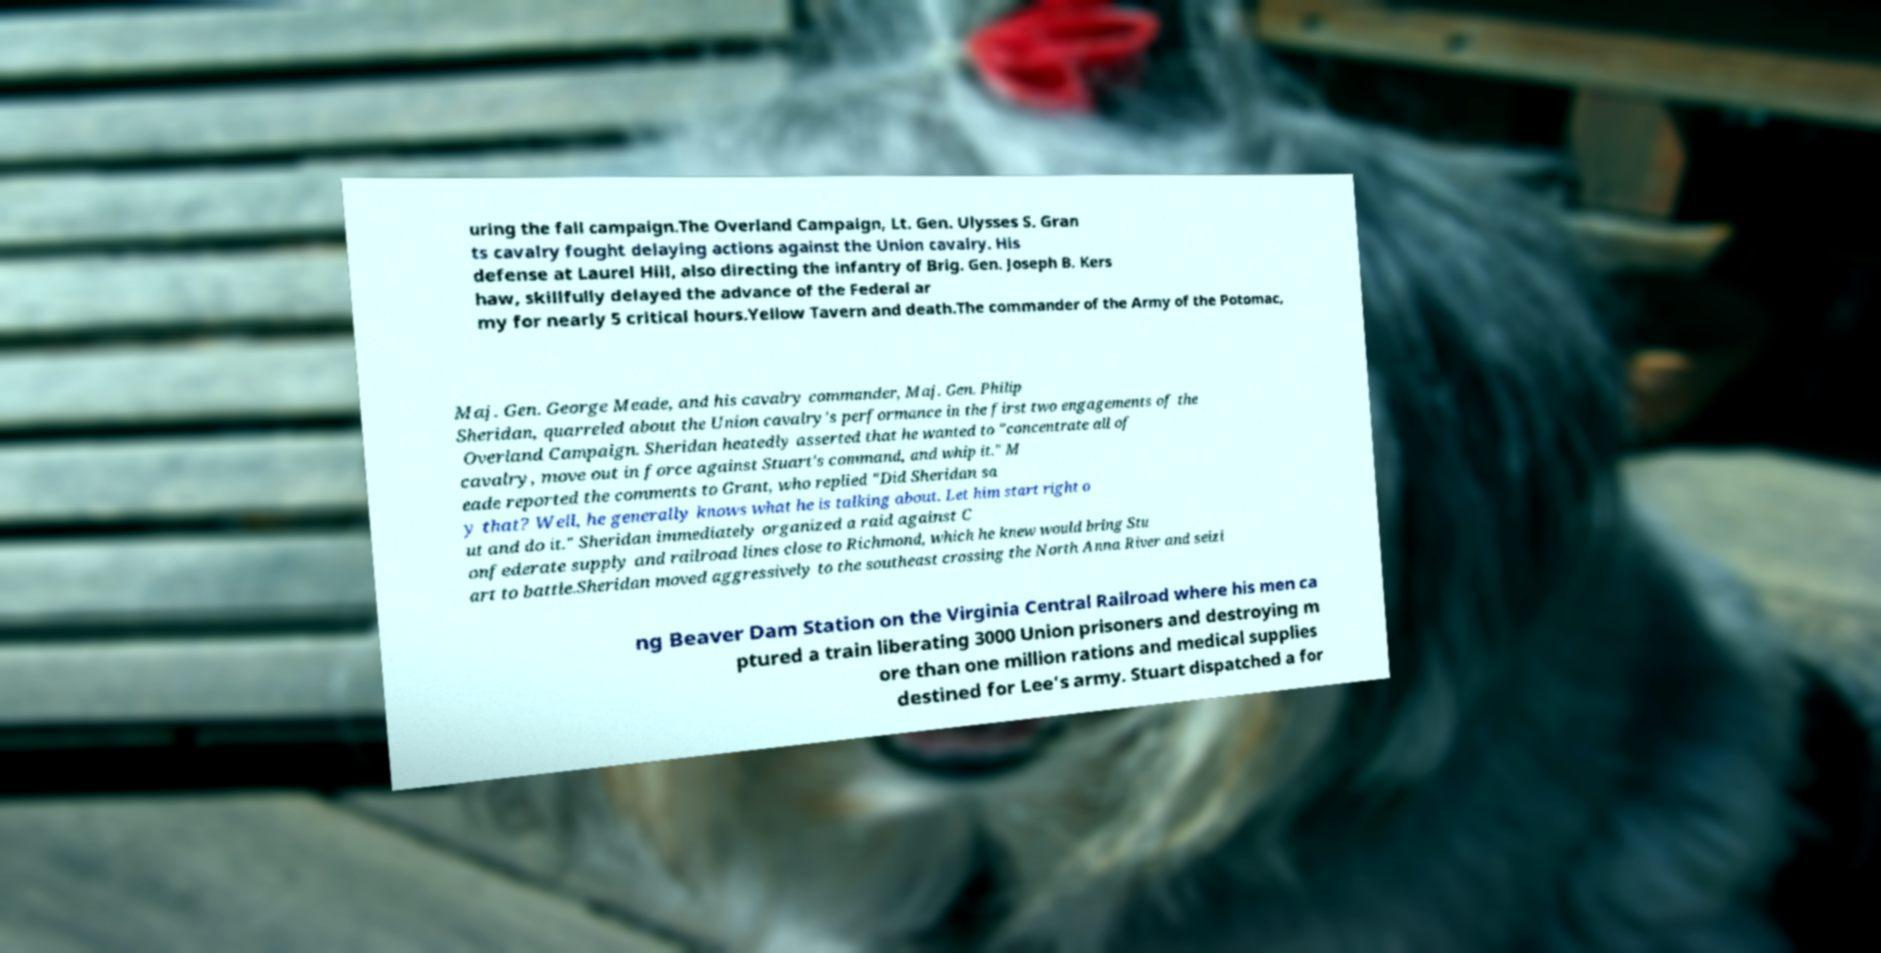I need the written content from this picture converted into text. Can you do that? uring the fall campaign.The Overland Campaign, Lt. Gen. Ulysses S. Gran ts cavalry fought delaying actions against the Union cavalry. His defense at Laurel Hill, also directing the infantry of Brig. Gen. Joseph B. Kers haw, skillfully delayed the advance of the Federal ar my for nearly 5 critical hours.Yellow Tavern and death.The commander of the Army of the Potomac, Maj. Gen. George Meade, and his cavalry commander, Maj. Gen. Philip Sheridan, quarreled about the Union cavalry's performance in the first two engagements of the Overland Campaign. Sheridan heatedly asserted that he wanted to "concentrate all of cavalry, move out in force against Stuart's command, and whip it." M eade reported the comments to Grant, who replied "Did Sheridan sa y that? Well, he generally knows what he is talking about. Let him start right o ut and do it." Sheridan immediately organized a raid against C onfederate supply and railroad lines close to Richmond, which he knew would bring Stu art to battle.Sheridan moved aggressively to the southeast crossing the North Anna River and seizi ng Beaver Dam Station on the Virginia Central Railroad where his men ca ptured a train liberating 3000 Union prisoners and destroying m ore than one million rations and medical supplies destined for Lee's army. Stuart dispatched a for 